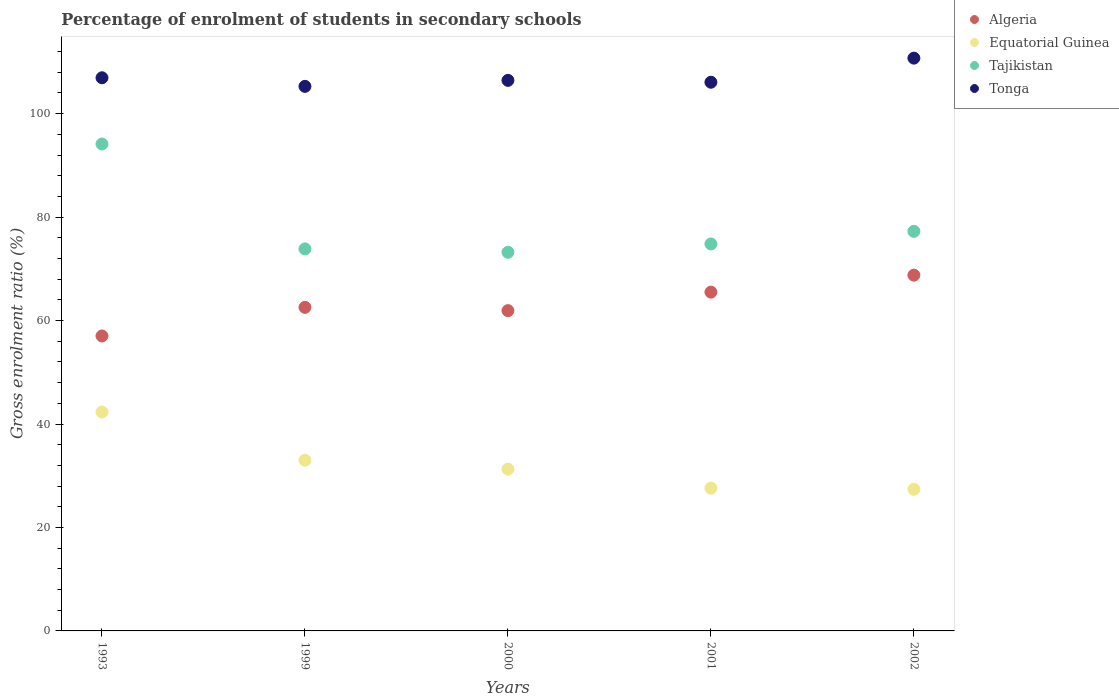How many different coloured dotlines are there?
Provide a short and direct response. 4. What is the percentage of students enrolled in secondary schools in Tajikistan in 1993?
Your response must be concise. 94.13. Across all years, what is the maximum percentage of students enrolled in secondary schools in Tonga?
Give a very brief answer. 110.73. Across all years, what is the minimum percentage of students enrolled in secondary schools in Tonga?
Your answer should be compact. 105.27. In which year was the percentage of students enrolled in secondary schools in Tajikistan maximum?
Ensure brevity in your answer.  1993. What is the total percentage of students enrolled in secondary schools in Tajikistan in the graph?
Make the answer very short. 393.25. What is the difference between the percentage of students enrolled in secondary schools in Tonga in 1999 and that in 2001?
Offer a terse response. -0.8. What is the difference between the percentage of students enrolled in secondary schools in Tonga in 2000 and the percentage of students enrolled in secondary schools in Tajikistan in 2001?
Ensure brevity in your answer.  31.62. What is the average percentage of students enrolled in secondary schools in Equatorial Guinea per year?
Provide a succinct answer. 32.32. In the year 2001, what is the difference between the percentage of students enrolled in secondary schools in Tonga and percentage of students enrolled in secondary schools in Algeria?
Your response must be concise. 40.58. In how many years, is the percentage of students enrolled in secondary schools in Tonga greater than 80 %?
Your response must be concise. 5. What is the ratio of the percentage of students enrolled in secondary schools in Equatorial Guinea in 1993 to that in 2001?
Your answer should be very brief. 1.53. Is the percentage of students enrolled in secondary schools in Tonga in 2000 less than that in 2002?
Provide a succinct answer. Yes. What is the difference between the highest and the second highest percentage of students enrolled in secondary schools in Algeria?
Provide a succinct answer. 3.28. What is the difference between the highest and the lowest percentage of students enrolled in secondary schools in Algeria?
Provide a short and direct response. 11.75. In how many years, is the percentage of students enrolled in secondary schools in Tonga greater than the average percentage of students enrolled in secondary schools in Tonga taken over all years?
Ensure brevity in your answer.  1. Is it the case that in every year, the sum of the percentage of students enrolled in secondary schools in Algeria and percentage of students enrolled in secondary schools in Tajikistan  is greater than the sum of percentage of students enrolled in secondary schools in Equatorial Guinea and percentage of students enrolled in secondary schools in Tonga?
Provide a succinct answer. Yes. Is the percentage of students enrolled in secondary schools in Tonga strictly greater than the percentage of students enrolled in secondary schools in Equatorial Guinea over the years?
Your response must be concise. Yes. How many years are there in the graph?
Offer a very short reply. 5. What is the difference between two consecutive major ticks on the Y-axis?
Offer a very short reply. 20. Are the values on the major ticks of Y-axis written in scientific E-notation?
Provide a short and direct response. No. Where does the legend appear in the graph?
Keep it short and to the point. Top right. How are the legend labels stacked?
Provide a short and direct response. Vertical. What is the title of the graph?
Make the answer very short. Percentage of enrolment of students in secondary schools. Does "Egypt, Arab Rep." appear as one of the legend labels in the graph?
Give a very brief answer. No. What is the label or title of the X-axis?
Offer a very short reply. Years. What is the Gross enrolment ratio (%) of Algeria in 1993?
Your response must be concise. 57.02. What is the Gross enrolment ratio (%) of Equatorial Guinea in 1993?
Make the answer very short. 42.32. What is the Gross enrolment ratio (%) in Tajikistan in 1993?
Offer a very short reply. 94.13. What is the Gross enrolment ratio (%) in Tonga in 1993?
Offer a terse response. 106.94. What is the Gross enrolment ratio (%) in Algeria in 1999?
Keep it short and to the point. 62.55. What is the Gross enrolment ratio (%) in Equatorial Guinea in 1999?
Your answer should be very brief. 33. What is the Gross enrolment ratio (%) in Tajikistan in 1999?
Offer a very short reply. 73.86. What is the Gross enrolment ratio (%) of Tonga in 1999?
Your response must be concise. 105.27. What is the Gross enrolment ratio (%) in Algeria in 2000?
Offer a terse response. 61.92. What is the Gross enrolment ratio (%) in Equatorial Guinea in 2000?
Your answer should be very brief. 31.28. What is the Gross enrolment ratio (%) of Tajikistan in 2000?
Give a very brief answer. 73.2. What is the Gross enrolment ratio (%) of Tonga in 2000?
Your answer should be very brief. 106.43. What is the Gross enrolment ratio (%) in Algeria in 2001?
Your response must be concise. 65.5. What is the Gross enrolment ratio (%) in Equatorial Guinea in 2001?
Offer a terse response. 27.6. What is the Gross enrolment ratio (%) of Tajikistan in 2001?
Offer a very short reply. 74.81. What is the Gross enrolment ratio (%) of Tonga in 2001?
Make the answer very short. 106.07. What is the Gross enrolment ratio (%) in Algeria in 2002?
Your answer should be very brief. 68.78. What is the Gross enrolment ratio (%) of Equatorial Guinea in 2002?
Ensure brevity in your answer.  27.38. What is the Gross enrolment ratio (%) of Tajikistan in 2002?
Your answer should be very brief. 77.25. What is the Gross enrolment ratio (%) in Tonga in 2002?
Your response must be concise. 110.73. Across all years, what is the maximum Gross enrolment ratio (%) of Algeria?
Make the answer very short. 68.78. Across all years, what is the maximum Gross enrolment ratio (%) in Equatorial Guinea?
Provide a succinct answer. 42.32. Across all years, what is the maximum Gross enrolment ratio (%) in Tajikistan?
Keep it short and to the point. 94.13. Across all years, what is the maximum Gross enrolment ratio (%) of Tonga?
Keep it short and to the point. 110.73. Across all years, what is the minimum Gross enrolment ratio (%) in Algeria?
Make the answer very short. 57.02. Across all years, what is the minimum Gross enrolment ratio (%) of Equatorial Guinea?
Give a very brief answer. 27.38. Across all years, what is the minimum Gross enrolment ratio (%) in Tajikistan?
Give a very brief answer. 73.2. Across all years, what is the minimum Gross enrolment ratio (%) of Tonga?
Make the answer very short. 105.27. What is the total Gross enrolment ratio (%) in Algeria in the graph?
Keep it short and to the point. 315.77. What is the total Gross enrolment ratio (%) of Equatorial Guinea in the graph?
Offer a terse response. 161.58. What is the total Gross enrolment ratio (%) in Tajikistan in the graph?
Offer a very short reply. 393.25. What is the total Gross enrolment ratio (%) of Tonga in the graph?
Make the answer very short. 535.45. What is the difference between the Gross enrolment ratio (%) of Algeria in 1993 and that in 1999?
Your answer should be very brief. -5.53. What is the difference between the Gross enrolment ratio (%) of Equatorial Guinea in 1993 and that in 1999?
Provide a short and direct response. 9.32. What is the difference between the Gross enrolment ratio (%) of Tajikistan in 1993 and that in 1999?
Keep it short and to the point. 20.28. What is the difference between the Gross enrolment ratio (%) in Tonga in 1993 and that in 1999?
Keep it short and to the point. 1.66. What is the difference between the Gross enrolment ratio (%) of Algeria in 1993 and that in 2000?
Provide a succinct answer. -4.9. What is the difference between the Gross enrolment ratio (%) of Equatorial Guinea in 1993 and that in 2000?
Your answer should be compact. 11.04. What is the difference between the Gross enrolment ratio (%) of Tajikistan in 1993 and that in 2000?
Your answer should be compact. 20.93. What is the difference between the Gross enrolment ratio (%) of Tonga in 1993 and that in 2000?
Offer a terse response. 0.5. What is the difference between the Gross enrolment ratio (%) in Algeria in 1993 and that in 2001?
Your answer should be compact. -8.47. What is the difference between the Gross enrolment ratio (%) of Equatorial Guinea in 1993 and that in 2001?
Your answer should be compact. 14.72. What is the difference between the Gross enrolment ratio (%) in Tajikistan in 1993 and that in 2001?
Provide a short and direct response. 19.32. What is the difference between the Gross enrolment ratio (%) in Tonga in 1993 and that in 2001?
Provide a short and direct response. 0.86. What is the difference between the Gross enrolment ratio (%) of Algeria in 1993 and that in 2002?
Provide a succinct answer. -11.75. What is the difference between the Gross enrolment ratio (%) in Equatorial Guinea in 1993 and that in 2002?
Offer a very short reply. 14.93. What is the difference between the Gross enrolment ratio (%) of Tajikistan in 1993 and that in 2002?
Your answer should be compact. 16.89. What is the difference between the Gross enrolment ratio (%) of Tonga in 1993 and that in 2002?
Your answer should be very brief. -3.8. What is the difference between the Gross enrolment ratio (%) of Algeria in 1999 and that in 2000?
Your response must be concise. 0.63. What is the difference between the Gross enrolment ratio (%) of Equatorial Guinea in 1999 and that in 2000?
Your response must be concise. 1.72. What is the difference between the Gross enrolment ratio (%) in Tajikistan in 1999 and that in 2000?
Your answer should be very brief. 0.66. What is the difference between the Gross enrolment ratio (%) of Tonga in 1999 and that in 2000?
Give a very brief answer. -1.16. What is the difference between the Gross enrolment ratio (%) in Algeria in 1999 and that in 2001?
Offer a terse response. -2.94. What is the difference between the Gross enrolment ratio (%) of Equatorial Guinea in 1999 and that in 2001?
Provide a short and direct response. 5.4. What is the difference between the Gross enrolment ratio (%) of Tajikistan in 1999 and that in 2001?
Give a very brief answer. -0.96. What is the difference between the Gross enrolment ratio (%) of Algeria in 1999 and that in 2002?
Your answer should be compact. -6.22. What is the difference between the Gross enrolment ratio (%) of Equatorial Guinea in 1999 and that in 2002?
Make the answer very short. 5.62. What is the difference between the Gross enrolment ratio (%) in Tajikistan in 1999 and that in 2002?
Give a very brief answer. -3.39. What is the difference between the Gross enrolment ratio (%) of Tonga in 1999 and that in 2002?
Ensure brevity in your answer.  -5.46. What is the difference between the Gross enrolment ratio (%) in Algeria in 2000 and that in 2001?
Ensure brevity in your answer.  -3.58. What is the difference between the Gross enrolment ratio (%) of Equatorial Guinea in 2000 and that in 2001?
Your response must be concise. 3.68. What is the difference between the Gross enrolment ratio (%) in Tajikistan in 2000 and that in 2001?
Provide a succinct answer. -1.61. What is the difference between the Gross enrolment ratio (%) in Tonga in 2000 and that in 2001?
Your response must be concise. 0.36. What is the difference between the Gross enrolment ratio (%) of Algeria in 2000 and that in 2002?
Offer a very short reply. -6.86. What is the difference between the Gross enrolment ratio (%) of Equatorial Guinea in 2000 and that in 2002?
Your response must be concise. 3.89. What is the difference between the Gross enrolment ratio (%) in Tajikistan in 2000 and that in 2002?
Your answer should be compact. -4.05. What is the difference between the Gross enrolment ratio (%) in Tonga in 2000 and that in 2002?
Offer a terse response. -4.3. What is the difference between the Gross enrolment ratio (%) in Algeria in 2001 and that in 2002?
Offer a very short reply. -3.28. What is the difference between the Gross enrolment ratio (%) in Equatorial Guinea in 2001 and that in 2002?
Provide a short and direct response. 0.22. What is the difference between the Gross enrolment ratio (%) in Tajikistan in 2001 and that in 2002?
Provide a succinct answer. -2.43. What is the difference between the Gross enrolment ratio (%) in Tonga in 2001 and that in 2002?
Keep it short and to the point. -4.66. What is the difference between the Gross enrolment ratio (%) of Algeria in 1993 and the Gross enrolment ratio (%) of Equatorial Guinea in 1999?
Offer a terse response. 24.02. What is the difference between the Gross enrolment ratio (%) in Algeria in 1993 and the Gross enrolment ratio (%) in Tajikistan in 1999?
Offer a terse response. -16.83. What is the difference between the Gross enrolment ratio (%) of Algeria in 1993 and the Gross enrolment ratio (%) of Tonga in 1999?
Give a very brief answer. -48.25. What is the difference between the Gross enrolment ratio (%) of Equatorial Guinea in 1993 and the Gross enrolment ratio (%) of Tajikistan in 1999?
Your response must be concise. -31.54. What is the difference between the Gross enrolment ratio (%) in Equatorial Guinea in 1993 and the Gross enrolment ratio (%) in Tonga in 1999?
Keep it short and to the point. -62.96. What is the difference between the Gross enrolment ratio (%) in Tajikistan in 1993 and the Gross enrolment ratio (%) in Tonga in 1999?
Offer a terse response. -11.14. What is the difference between the Gross enrolment ratio (%) of Algeria in 1993 and the Gross enrolment ratio (%) of Equatorial Guinea in 2000?
Offer a terse response. 25.75. What is the difference between the Gross enrolment ratio (%) of Algeria in 1993 and the Gross enrolment ratio (%) of Tajikistan in 2000?
Provide a succinct answer. -16.18. What is the difference between the Gross enrolment ratio (%) of Algeria in 1993 and the Gross enrolment ratio (%) of Tonga in 2000?
Ensure brevity in your answer.  -49.41. What is the difference between the Gross enrolment ratio (%) in Equatorial Guinea in 1993 and the Gross enrolment ratio (%) in Tajikistan in 2000?
Provide a short and direct response. -30.88. What is the difference between the Gross enrolment ratio (%) in Equatorial Guinea in 1993 and the Gross enrolment ratio (%) in Tonga in 2000?
Ensure brevity in your answer.  -64.12. What is the difference between the Gross enrolment ratio (%) of Tajikistan in 1993 and the Gross enrolment ratio (%) of Tonga in 2000?
Give a very brief answer. -12.3. What is the difference between the Gross enrolment ratio (%) in Algeria in 1993 and the Gross enrolment ratio (%) in Equatorial Guinea in 2001?
Offer a very short reply. 29.42. What is the difference between the Gross enrolment ratio (%) of Algeria in 1993 and the Gross enrolment ratio (%) of Tajikistan in 2001?
Keep it short and to the point. -17.79. What is the difference between the Gross enrolment ratio (%) of Algeria in 1993 and the Gross enrolment ratio (%) of Tonga in 2001?
Give a very brief answer. -49.05. What is the difference between the Gross enrolment ratio (%) of Equatorial Guinea in 1993 and the Gross enrolment ratio (%) of Tajikistan in 2001?
Provide a short and direct response. -32.5. What is the difference between the Gross enrolment ratio (%) of Equatorial Guinea in 1993 and the Gross enrolment ratio (%) of Tonga in 2001?
Offer a terse response. -63.76. What is the difference between the Gross enrolment ratio (%) in Tajikistan in 1993 and the Gross enrolment ratio (%) in Tonga in 2001?
Provide a succinct answer. -11.94. What is the difference between the Gross enrolment ratio (%) of Algeria in 1993 and the Gross enrolment ratio (%) of Equatorial Guinea in 2002?
Offer a terse response. 29.64. What is the difference between the Gross enrolment ratio (%) in Algeria in 1993 and the Gross enrolment ratio (%) in Tajikistan in 2002?
Your answer should be compact. -20.22. What is the difference between the Gross enrolment ratio (%) of Algeria in 1993 and the Gross enrolment ratio (%) of Tonga in 2002?
Your response must be concise. -53.71. What is the difference between the Gross enrolment ratio (%) of Equatorial Guinea in 1993 and the Gross enrolment ratio (%) of Tajikistan in 2002?
Ensure brevity in your answer.  -34.93. What is the difference between the Gross enrolment ratio (%) of Equatorial Guinea in 1993 and the Gross enrolment ratio (%) of Tonga in 2002?
Offer a very short reply. -68.42. What is the difference between the Gross enrolment ratio (%) of Tajikistan in 1993 and the Gross enrolment ratio (%) of Tonga in 2002?
Provide a short and direct response. -16.6. What is the difference between the Gross enrolment ratio (%) of Algeria in 1999 and the Gross enrolment ratio (%) of Equatorial Guinea in 2000?
Your response must be concise. 31.28. What is the difference between the Gross enrolment ratio (%) of Algeria in 1999 and the Gross enrolment ratio (%) of Tajikistan in 2000?
Offer a terse response. -10.65. What is the difference between the Gross enrolment ratio (%) in Algeria in 1999 and the Gross enrolment ratio (%) in Tonga in 2000?
Your answer should be very brief. -43.88. What is the difference between the Gross enrolment ratio (%) in Equatorial Guinea in 1999 and the Gross enrolment ratio (%) in Tajikistan in 2000?
Offer a terse response. -40.2. What is the difference between the Gross enrolment ratio (%) of Equatorial Guinea in 1999 and the Gross enrolment ratio (%) of Tonga in 2000?
Your response must be concise. -73.43. What is the difference between the Gross enrolment ratio (%) of Tajikistan in 1999 and the Gross enrolment ratio (%) of Tonga in 2000?
Keep it short and to the point. -32.58. What is the difference between the Gross enrolment ratio (%) in Algeria in 1999 and the Gross enrolment ratio (%) in Equatorial Guinea in 2001?
Make the answer very short. 34.95. What is the difference between the Gross enrolment ratio (%) of Algeria in 1999 and the Gross enrolment ratio (%) of Tajikistan in 2001?
Your response must be concise. -12.26. What is the difference between the Gross enrolment ratio (%) in Algeria in 1999 and the Gross enrolment ratio (%) in Tonga in 2001?
Ensure brevity in your answer.  -43.52. What is the difference between the Gross enrolment ratio (%) in Equatorial Guinea in 1999 and the Gross enrolment ratio (%) in Tajikistan in 2001?
Give a very brief answer. -41.81. What is the difference between the Gross enrolment ratio (%) in Equatorial Guinea in 1999 and the Gross enrolment ratio (%) in Tonga in 2001?
Keep it short and to the point. -73.07. What is the difference between the Gross enrolment ratio (%) in Tajikistan in 1999 and the Gross enrolment ratio (%) in Tonga in 2001?
Provide a short and direct response. -32.22. What is the difference between the Gross enrolment ratio (%) of Algeria in 1999 and the Gross enrolment ratio (%) of Equatorial Guinea in 2002?
Your answer should be very brief. 35.17. What is the difference between the Gross enrolment ratio (%) of Algeria in 1999 and the Gross enrolment ratio (%) of Tajikistan in 2002?
Offer a terse response. -14.69. What is the difference between the Gross enrolment ratio (%) in Algeria in 1999 and the Gross enrolment ratio (%) in Tonga in 2002?
Give a very brief answer. -48.18. What is the difference between the Gross enrolment ratio (%) in Equatorial Guinea in 1999 and the Gross enrolment ratio (%) in Tajikistan in 2002?
Provide a short and direct response. -44.25. What is the difference between the Gross enrolment ratio (%) of Equatorial Guinea in 1999 and the Gross enrolment ratio (%) of Tonga in 2002?
Offer a very short reply. -77.73. What is the difference between the Gross enrolment ratio (%) in Tajikistan in 1999 and the Gross enrolment ratio (%) in Tonga in 2002?
Your response must be concise. -36.88. What is the difference between the Gross enrolment ratio (%) in Algeria in 2000 and the Gross enrolment ratio (%) in Equatorial Guinea in 2001?
Your answer should be compact. 34.32. What is the difference between the Gross enrolment ratio (%) of Algeria in 2000 and the Gross enrolment ratio (%) of Tajikistan in 2001?
Your answer should be very brief. -12.89. What is the difference between the Gross enrolment ratio (%) in Algeria in 2000 and the Gross enrolment ratio (%) in Tonga in 2001?
Provide a succinct answer. -44.15. What is the difference between the Gross enrolment ratio (%) of Equatorial Guinea in 2000 and the Gross enrolment ratio (%) of Tajikistan in 2001?
Your answer should be compact. -43.54. What is the difference between the Gross enrolment ratio (%) in Equatorial Guinea in 2000 and the Gross enrolment ratio (%) in Tonga in 2001?
Offer a very short reply. -74.8. What is the difference between the Gross enrolment ratio (%) in Tajikistan in 2000 and the Gross enrolment ratio (%) in Tonga in 2001?
Provide a succinct answer. -32.87. What is the difference between the Gross enrolment ratio (%) of Algeria in 2000 and the Gross enrolment ratio (%) of Equatorial Guinea in 2002?
Provide a succinct answer. 34.54. What is the difference between the Gross enrolment ratio (%) of Algeria in 2000 and the Gross enrolment ratio (%) of Tajikistan in 2002?
Your answer should be compact. -15.33. What is the difference between the Gross enrolment ratio (%) in Algeria in 2000 and the Gross enrolment ratio (%) in Tonga in 2002?
Give a very brief answer. -48.81. What is the difference between the Gross enrolment ratio (%) of Equatorial Guinea in 2000 and the Gross enrolment ratio (%) of Tajikistan in 2002?
Your answer should be very brief. -45.97. What is the difference between the Gross enrolment ratio (%) of Equatorial Guinea in 2000 and the Gross enrolment ratio (%) of Tonga in 2002?
Offer a very short reply. -79.46. What is the difference between the Gross enrolment ratio (%) of Tajikistan in 2000 and the Gross enrolment ratio (%) of Tonga in 2002?
Keep it short and to the point. -37.53. What is the difference between the Gross enrolment ratio (%) of Algeria in 2001 and the Gross enrolment ratio (%) of Equatorial Guinea in 2002?
Offer a very short reply. 38.11. What is the difference between the Gross enrolment ratio (%) of Algeria in 2001 and the Gross enrolment ratio (%) of Tajikistan in 2002?
Provide a short and direct response. -11.75. What is the difference between the Gross enrolment ratio (%) in Algeria in 2001 and the Gross enrolment ratio (%) in Tonga in 2002?
Make the answer very short. -45.24. What is the difference between the Gross enrolment ratio (%) in Equatorial Guinea in 2001 and the Gross enrolment ratio (%) in Tajikistan in 2002?
Give a very brief answer. -49.65. What is the difference between the Gross enrolment ratio (%) in Equatorial Guinea in 2001 and the Gross enrolment ratio (%) in Tonga in 2002?
Your answer should be very brief. -83.13. What is the difference between the Gross enrolment ratio (%) of Tajikistan in 2001 and the Gross enrolment ratio (%) of Tonga in 2002?
Ensure brevity in your answer.  -35.92. What is the average Gross enrolment ratio (%) in Algeria per year?
Offer a very short reply. 63.15. What is the average Gross enrolment ratio (%) of Equatorial Guinea per year?
Ensure brevity in your answer.  32.32. What is the average Gross enrolment ratio (%) in Tajikistan per year?
Your answer should be very brief. 78.65. What is the average Gross enrolment ratio (%) in Tonga per year?
Offer a terse response. 107.09. In the year 1993, what is the difference between the Gross enrolment ratio (%) in Algeria and Gross enrolment ratio (%) in Equatorial Guinea?
Offer a very short reply. 14.71. In the year 1993, what is the difference between the Gross enrolment ratio (%) of Algeria and Gross enrolment ratio (%) of Tajikistan?
Provide a succinct answer. -37.11. In the year 1993, what is the difference between the Gross enrolment ratio (%) of Algeria and Gross enrolment ratio (%) of Tonga?
Provide a short and direct response. -49.91. In the year 1993, what is the difference between the Gross enrolment ratio (%) of Equatorial Guinea and Gross enrolment ratio (%) of Tajikistan?
Ensure brevity in your answer.  -51.82. In the year 1993, what is the difference between the Gross enrolment ratio (%) of Equatorial Guinea and Gross enrolment ratio (%) of Tonga?
Your answer should be very brief. -64.62. In the year 1993, what is the difference between the Gross enrolment ratio (%) in Tajikistan and Gross enrolment ratio (%) in Tonga?
Your answer should be very brief. -12.8. In the year 1999, what is the difference between the Gross enrolment ratio (%) in Algeria and Gross enrolment ratio (%) in Equatorial Guinea?
Provide a succinct answer. 29.55. In the year 1999, what is the difference between the Gross enrolment ratio (%) in Algeria and Gross enrolment ratio (%) in Tajikistan?
Your response must be concise. -11.3. In the year 1999, what is the difference between the Gross enrolment ratio (%) in Algeria and Gross enrolment ratio (%) in Tonga?
Provide a short and direct response. -42.72. In the year 1999, what is the difference between the Gross enrolment ratio (%) of Equatorial Guinea and Gross enrolment ratio (%) of Tajikistan?
Give a very brief answer. -40.86. In the year 1999, what is the difference between the Gross enrolment ratio (%) of Equatorial Guinea and Gross enrolment ratio (%) of Tonga?
Your answer should be very brief. -72.27. In the year 1999, what is the difference between the Gross enrolment ratio (%) in Tajikistan and Gross enrolment ratio (%) in Tonga?
Provide a succinct answer. -31.42. In the year 2000, what is the difference between the Gross enrolment ratio (%) in Algeria and Gross enrolment ratio (%) in Equatorial Guinea?
Offer a very short reply. 30.64. In the year 2000, what is the difference between the Gross enrolment ratio (%) of Algeria and Gross enrolment ratio (%) of Tajikistan?
Ensure brevity in your answer.  -11.28. In the year 2000, what is the difference between the Gross enrolment ratio (%) in Algeria and Gross enrolment ratio (%) in Tonga?
Give a very brief answer. -44.51. In the year 2000, what is the difference between the Gross enrolment ratio (%) of Equatorial Guinea and Gross enrolment ratio (%) of Tajikistan?
Your answer should be very brief. -41.92. In the year 2000, what is the difference between the Gross enrolment ratio (%) in Equatorial Guinea and Gross enrolment ratio (%) in Tonga?
Give a very brief answer. -75.16. In the year 2000, what is the difference between the Gross enrolment ratio (%) in Tajikistan and Gross enrolment ratio (%) in Tonga?
Give a very brief answer. -33.23. In the year 2001, what is the difference between the Gross enrolment ratio (%) in Algeria and Gross enrolment ratio (%) in Equatorial Guinea?
Make the answer very short. 37.9. In the year 2001, what is the difference between the Gross enrolment ratio (%) in Algeria and Gross enrolment ratio (%) in Tajikistan?
Your answer should be very brief. -9.32. In the year 2001, what is the difference between the Gross enrolment ratio (%) in Algeria and Gross enrolment ratio (%) in Tonga?
Provide a short and direct response. -40.58. In the year 2001, what is the difference between the Gross enrolment ratio (%) of Equatorial Guinea and Gross enrolment ratio (%) of Tajikistan?
Your answer should be very brief. -47.21. In the year 2001, what is the difference between the Gross enrolment ratio (%) of Equatorial Guinea and Gross enrolment ratio (%) of Tonga?
Make the answer very short. -78.47. In the year 2001, what is the difference between the Gross enrolment ratio (%) of Tajikistan and Gross enrolment ratio (%) of Tonga?
Your response must be concise. -31.26. In the year 2002, what is the difference between the Gross enrolment ratio (%) in Algeria and Gross enrolment ratio (%) in Equatorial Guinea?
Your response must be concise. 41.4. In the year 2002, what is the difference between the Gross enrolment ratio (%) in Algeria and Gross enrolment ratio (%) in Tajikistan?
Make the answer very short. -8.47. In the year 2002, what is the difference between the Gross enrolment ratio (%) of Algeria and Gross enrolment ratio (%) of Tonga?
Offer a terse response. -41.95. In the year 2002, what is the difference between the Gross enrolment ratio (%) of Equatorial Guinea and Gross enrolment ratio (%) of Tajikistan?
Ensure brevity in your answer.  -49.86. In the year 2002, what is the difference between the Gross enrolment ratio (%) of Equatorial Guinea and Gross enrolment ratio (%) of Tonga?
Your answer should be very brief. -83.35. In the year 2002, what is the difference between the Gross enrolment ratio (%) of Tajikistan and Gross enrolment ratio (%) of Tonga?
Ensure brevity in your answer.  -33.49. What is the ratio of the Gross enrolment ratio (%) in Algeria in 1993 to that in 1999?
Your response must be concise. 0.91. What is the ratio of the Gross enrolment ratio (%) of Equatorial Guinea in 1993 to that in 1999?
Give a very brief answer. 1.28. What is the ratio of the Gross enrolment ratio (%) in Tajikistan in 1993 to that in 1999?
Give a very brief answer. 1.27. What is the ratio of the Gross enrolment ratio (%) in Tonga in 1993 to that in 1999?
Offer a terse response. 1.02. What is the ratio of the Gross enrolment ratio (%) in Algeria in 1993 to that in 2000?
Your response must be concise. 0.92. What is the ratio of the Gross enrolment ratio (%) in Equatorial Guinea in 1993 to that in 2000?
Ensure brevity in your answer.  1.35. What is the ratio of the Gross enrolment ratio (%) of Tajikistan in 1993 to that in 2000?
Provide a short and direct response. 1.29. What is the ratio of the Gross enrolment ratio (%) in Tonga in 1993 to that in 2000?
Offer a very short reply. 1. What is the ratio of the Gross enrolment ratio (%) in Algeria in 1993 to that in 2001?
Make the answer very short. 0.87. What is the ratio of the Gross enrolment ratio (%) of Equatorial Guinea in 1993 to that in 2001?
Offer a terse response. 1.53. What is the ratio of the Gross enrolment ratio (%) in Tajikistan in 1993 to that in 2001?
Give a very brief answer. 1.26. What is the ratio of the Gross enrolment ratio (%) of Tonga in 1993 to that in 2001?
Offer a terse response. 1.01. What is the ratio of the Gross enrolment ratio (%) in Algeria in 1993 to that in 2002?
Offer a very short reply. 0.83. What is the ratio of the Gross enrolment ratio (%) in Equatorial Guinea in 1993 to that in 2002?
Give a very brief answer. 1.55. What is the ratio of the Gross enrolment ratio (%) in Tajikistan in 1993 to that in 2002?
Your response must be concise. 1.22. What is the ratio of the Gross enrolment ratio (%) of Tonga in 1993 to that in 2002?
Provide a succinct answer. 0.97. What is the ratio of the Gross enrolment ratio (%) in Algeria in 1999 to that in 2000?
Provide a succinct answer. 1.01. What is the ratio of the Gross enrolment ratio (%) of Equatorial Guinea in 1999 to that in 2000?
Provide a short and direct response. 1.06. What is the ratio of the Gross enrolment ratio (%) of Algeria in 1999 to that in 2001?
Make the answer very short. 0.96. What is the ratio of the Gross enrolment ratio (%) in Equatorial Guinea in 1999 to that in 2001?
Your response must be concise. 1.2. What is the ratio of the Gross enrolment ratio (%) in Tajikistan in 1999 to that in 2001?
Ensure brevity in your answer.  0.99. What is the ratio of the Gross enrolment ratio (%) of Tonga in 1999 to that in 2001?
Provide a succinct answer. 0.99. What is the ratio of the Gross enrolment ratio (%) of Algeria in 1999 to that in 2002?
Your answer should be very brief. 0.91. What is the ratio of the Gross enrolment ratio (%) in Equatorial Guinea in 1999 to that in 2002?
Give a very brief answer. 1.21. What is the ratio of the Gross enrolment ratio (%) of Tajikistan in 1999 to that in 2002?
Provide a succinct answer. 0.96. What is the ratio of the Gross enrolment ratio (%) in Tonga in 1999 to that in 2002?
Provide a succinct answer. 0.95. What is the ratio of the Gross enrolment ratio (%) in Algeria in 2000 to that in 2001?
Your answer should be very brief. 0.95. What is the ratio of the Gross enrolment ratio (%) of Equatorial Guinea in 2000 to that in 2001?
Provide a succinct answer. 1.13. What is the ratio of the Gross enrolment ratio (%) of Tajikistan in 2000 to that in 2001?
Provide a short and direct response. 0.98. What is the ratio of the Gross enrolment ratio (%) of Algeria in 2000 to that in 2002?
Provide a short and direct response. 0.9. What is the ratio of the Gross enrolment ratio (%) of Equatorial Guinea in 2000 to that in 2002?
Provide a succinct answer. 1.14. What is the ratio of the Gross enrolment ratio (%) of Tajikistan in 2000 to that in 2002?
Your response must be concise. 0.95. What is the ratio of the Gross enrolment ratio (%) in Tonga in 2000 to that in 2002?
Provide a succinct answer. 0.96. What is the ratio of the Gross enrolment ratio (%) of Algeria in 2001 to that in 2002?
Keep it short and to the point. 0.95. What is the ratio of the Gross enrolment ratio (%) in Equatorial Guinea in 2001 to that in 2002?
Your response must be concise. 1.01. What is the ratio of the Gross enrolment ratio (%) of Tajikistan in 2001 to that in 2002?
Provide a short and direct response. 0.97. What is the ratio of the Gross enrolment ratio (%) of Tonga in 2001 to that in 2002?
Your answer should be compact. 0.96. What is the difference between the highest and the second highest Gross enrolment ratio (%) of Algeria?
Your response must be concise. 3.28. What is the difference between the highest and the second highest Gross enrolment ratio (%) of Equatorial Guinea?
Make the answer very short. 9.32. What is the difference between the highest and the second highest Gross enrolment ratio (%) of Tajikistan?
Make the answer very short. 16.89. What is the difference between the highest and the second highest Gross enrolment ratio (%) of Tonga?
Provide a succinct answer. 3.8. What is the difference between the highest and the lowest Gross enrolment ratio (%) of Algeria?
Keep it short and to the point. 11.75. What is the difference between the highest and the lowest Gross enrolment ratio (%) in Equatorial Guinea?
Offer a terse response. 14.93. What is the difference between the highest and the lowest Gross enrolment ratio (%) in Tajikistan?
Provide a succinct answer. 20.93. What is the difference between the highest and the lowest Gross enrolment ratio (%) of Tonga?
Your response must be concise. 5.46. 